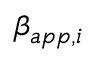<formula> <loc_0><loc_0><loc_500><loc_500>\beta _ { a p p , i }</formula> 